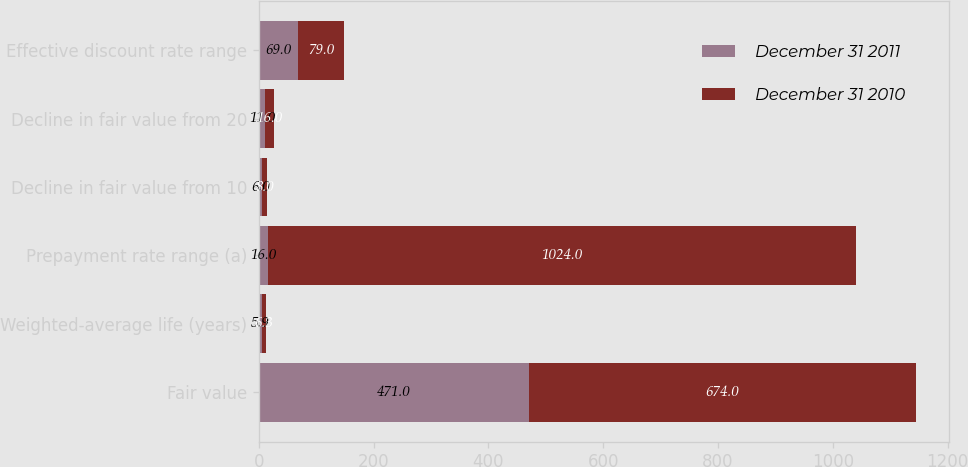<chart> <loc_0><loc_0><loc_500><loc_500><stacked_bar_chart><ecel><fcel>Fair value<fcel>Weighted-average life (years)<fcel>Prepayment rate range (a)<fcel>Decline in fair value from 10<fcel>Decline in fair value from 20<fcel>Effective discount rate range<nl><fcel>December 31 2011<fcel>471<fcel>5.9<fcel>16<fcel>6<fcel>11<fcel>69<nl><fcel>December 31 2010<fcel>674<fcel>6.3<fcel>1024<fcel>8<fcel>16<fcel>79<nl></chart> 